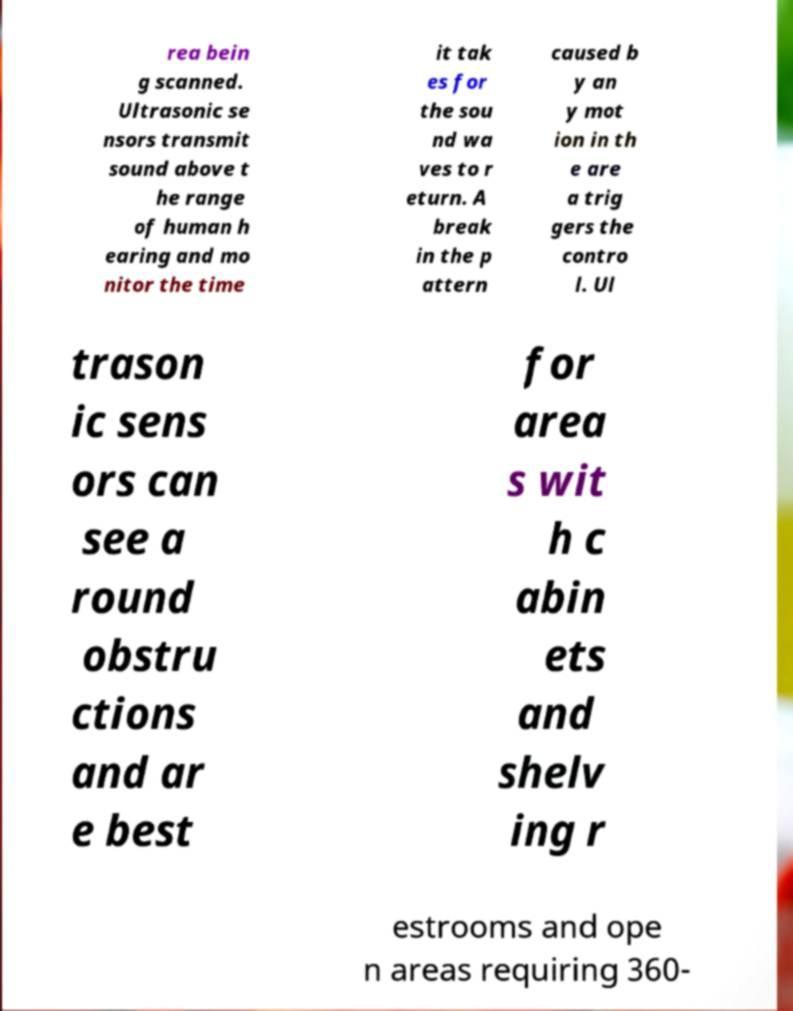Please read and relay the text visible in this image. What does it say? rea bein g scanned. Ultrasonic se nsors transmit sound above t he range of human h earing and mo nitor the time it tak es for the sou nd wa ves to r eturn. A break in the p attern caused b y an y mot ion in th e are a trig gers the contro l. Ul trason ic sens ors can see a round obstru ctions and ar e best for area s wit h c abin ets and shelv ing r estrooms and ope n areas requiring 360- 